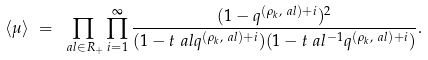Convert formula to latex. <formula><loc_0><loc_0><loc_500><loc_500>& \langle \mu \rangle \ = \ \prod _ { \ a l \in R _ { + } } \prod _ { i = 1 } ^ { \infty } \frac { ( 1 - q ^ { ( \rho _ { k } , \ a l ) + i } ) ^ { 2 } } { ( 1 - t _ { \ } a l q ^ { ( \rho _ { k } , \ a l ) + i } ) ( 1 - t _ { \ } a l ^ { - 1 } q ^ { ( \rho _ { k } , \ a l ) + i } ) } .</formula> 